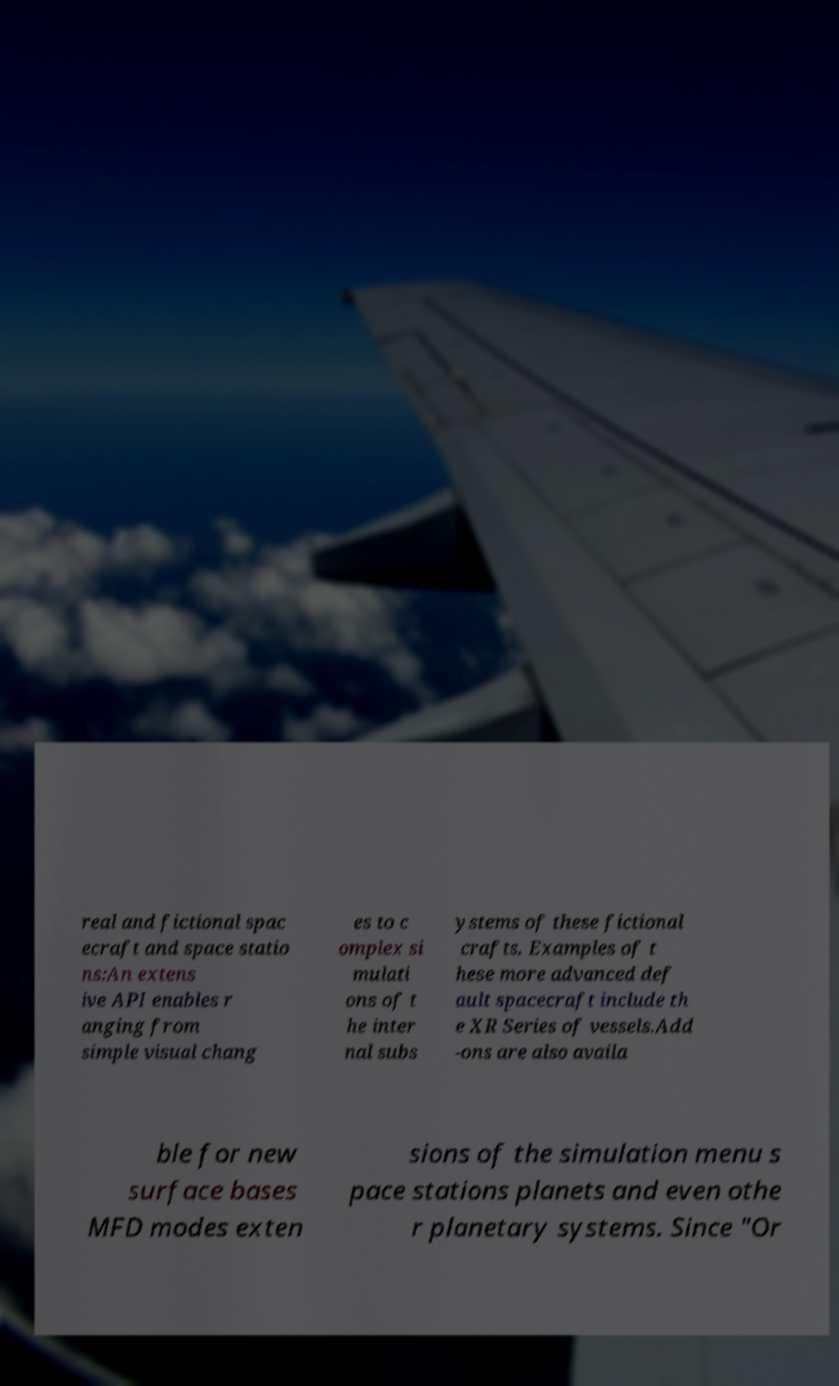Please identify and transcribe the text found in this image. real and fictional spac ecraft and space statio ns:An extens ive API enables r anging from simple visual chang es to c omplex si mulati ons of t he inter nal subs ystems of these fictional crafts. Examples of t hese more advanced def ault spacecraft include th e XR Series of vessels.Add -ons are also availa ble for new surface bases MFD modes exten sions of the simulation menu s pace stations planets and even othe r planetary systems. Since "Or 